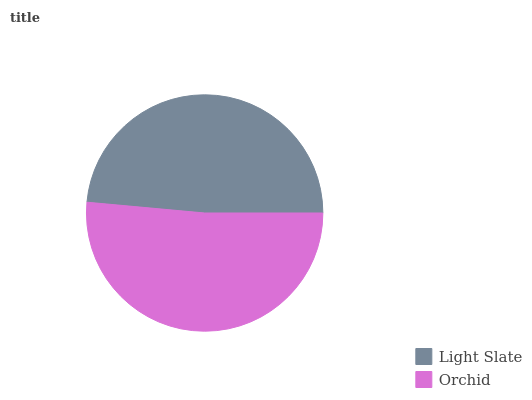Is Light Slate the minimum?
Answer yes or no. Yes. Is Orchid the maximum?
Answer yes or no. Yes. Is Orchid the minimum?
Answer yes or no. No. Is Orchid greater than Light Slate?
Answer yes or no. Yes. Is Light Slate less than Orchid?
Answer yes or no. Yes. Is Light Slate greater than Orchid?
Answer yes or no. No. Is Orchid less than Light Slate?
Answer yes or no. No. Is Orchid the high median?
Answer yes or no. Yes. Is Light Slate the low median?
Answer yes or no. Yes. Is Light Slate the high median?
Answer yes or no. No. Is Orchid the low median?
Answer yes or no. No. 